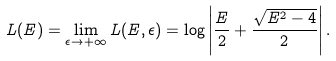<formula> <loc_0><loc_0><loc_500><loc_500>L ( E ) = \lim _ { \epsilon \rightarrow + \infty } L ( E , \epsilon ) = \log \left | \frac { E } { 2 } + \frac { \sqrt { E ^ { 2 } - 4 } } { 2 } \right | .</formula> 